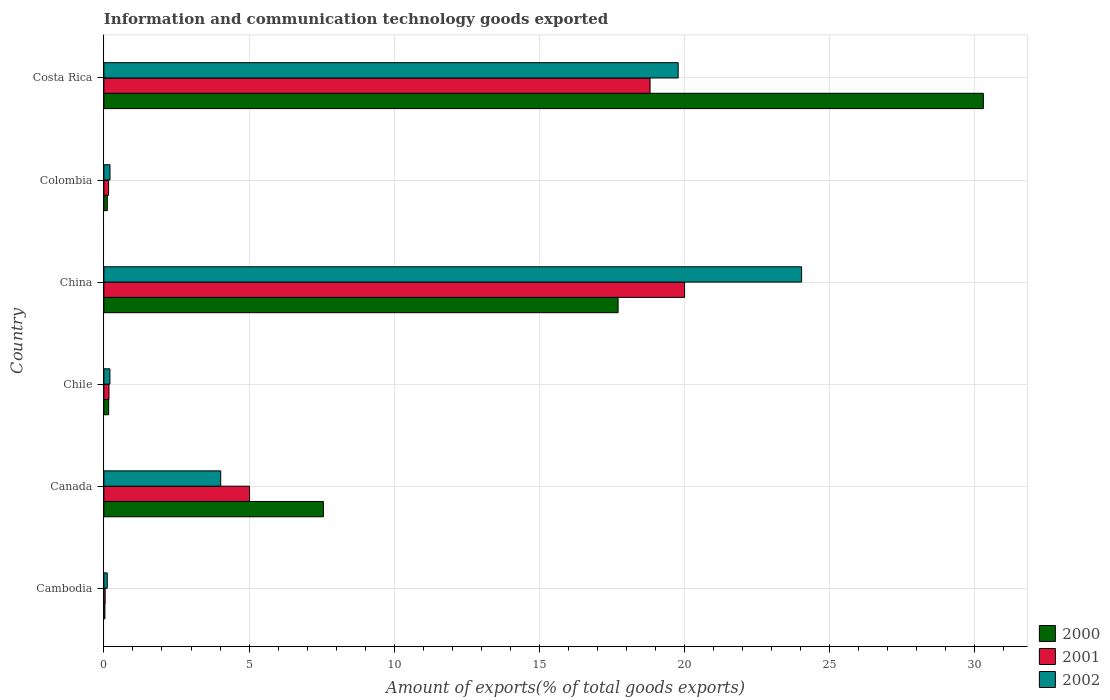How many different coloured bars are there?
Your response must be concise. 3. Are the number of bars per tick equal to the number of legend labels?
Your answer should be compact. Yes. In how many cases, is the number of bars for a given country not equal to the number of legend labels?
Offer a very short reply. 0. What is the amount of goods exported in 2002 in China?
Your answer should be very brief. 24.03. Across all countries, what is the maximum amount of goods exported in 2001?
Provide a succinct answer. 20. Across all countries, what is the minimum amount of goods exported in 2002?
Provide a short and direct response. 0.12. In which country was the amount of goods exported in 2000 maximum?
Your answer should be very brief. Costa Rica. In which country was the amount of goods exported in 2000 minimum?
Provide a succinct answer. Cambodia. What is the total amount of goods exported in 2002 in the graph?
Ensure brevity in your answer.  48.37. What is the difference between the amount of goods exported in 2001 in Colombia and that in Costa Rica?
Make the answer very short. -18.65. What is the difference between the amount of goods exported in 2002 in Canada and the amount of goods exported in 2001 in Chile?
Provide a short and direct response. 3.85. What is the average amount of goods exported in 2002 per country?
Your response must be concise. 8.06. What is the difference between the amount of goods exported in 2000 and amount of goods exported in 2002 in Chile?
Provide a short and direct response. -0.04. In how many countries, is the amount of goods exported in 2002 greater than 3 %?
Offer a terse response. 3. What is the ratio of the amount of goods exported in 2000 in Cambodia to that in Costa Rica?
Keep it short and to the point. 0. Is the amount of goods exported in 2001 in Chile less than that in Costa Rica?
Your answer should be compact. Yes. Is the difference between the amount of goods exported in 2000 in China and Colombia greater than the difference between the amount of goods exported in 2002 in China and Colombia?
Your answer should be compact. No. What is the difference between the highest and the second highest amount of goods exported in 2000?
Your response must be concise. 12.58. What is the difference between the highest and the lowest amount of goods exported in 2000?
Make the answer very short. 30.26. What does the 1st bar from the top in China represents?
Keep it short and to the point. 2002. Is it the case that in every country, the sum of the amount of goods exported in 2002 and amount of goods exported in 2001 is greater than the amount of goods exported in 2000?
Provide a succinct answer. Yes. How many bars are there?
Keep it short and to the point. 18. What is the difference between two consecutive major ticks on the X-axis?
Provide a short and direct response. 5. Does the graph contain any zero values?
Your response must be concise. No. How are the legend labels stacked?
Make the answer very short. Vertical. What is the title of the graph?
Make the answer very short. Information and communication technology goods exported. What is the label or title of the X-axis?
Your answer should be very brief. Amount of exports(% of total goods exports). What is the label or title of the Y-axis?
Keep it short and to the point. Country. What is the Amount of exports(% of total goods exports) in 2000 in Cambodia?
Give a very brief answer. 0.04. What is the Amount of exports(% of total goods exports) of 2001 in Cambodia?
Your answer should be compact. 0.04. What is the Amount of exports(% of total goods exports) in 2002 in Cambodia?
Ensure brevity in your answer.  0.12. What is the Amount of exports(% of total goods exports) in 2000 in Canada?
Provide a short and direct response. 7.56. What is the Amount of exports(% of total goods exports) in 2001 in Canada?
Offer a terse response. 5.02. What is the Amount of exports(% of total goods exports) in 2002 in Canada?
Ensure brevity in your answer.  4.02. What is the Amount of exports(% of total goods exports) in 2000 in Chile?
Your answer should be compact. 0.16. What is the Amount of exports(% of total goods exports) of 2001 in Chile?
Offer a terse response. 0.18. What is the Amount of exports(% of total goods exports) in 2002 in Chile?
Offer a very short reply. 0.21. What is the Amount of exports(% of total goods exports) of 2000 in China?
Give a very brief answer. 17.71. What is the Amount of exports(% of total goods exports) in 2001 in China?
Keep it short and to the point. 20. What is the Amount of exports(% of total goods exports) of 2002 in China?
Keep it short and to the point. 24.03. What is the Amount of exports(% of total goods exports) of 2000 in Colombia?
Make the answer very short. 0.12. What is the Amount of exports(% of total goods exports) of 2001 in Colombia?
Provide a short and direct response. 0.16. What is the Amount of exports(% of total goods exports) of 2002 in Colombia?
Provide a succinct answer. 0.21. What is the Amount of exports(% of total goods exports) of 2000 in Costa Rica?
Provide a short and direct response. 30.29. What is the Amount of exports(% of total goods exports) of 2001 in Costa Rica?
Offer a very short reply. 18.81. What is the Amount of exports(% of total goods exports) of 2002 in Costa Rica?
Provide a short and direct response. 19.78. Across all countries, what is the maximum Amount of exports(% of total goods exports) in 2000?
Keep it short and to the point. 30.29. Across all countries, what is the maximum Amount of exports(% of total goods exports) in 2001?
Provide a short and direct response. 20. Across all countries, what is the maximum Amount of exports(% of total goods exports) in 2002?
Your response must be concise. 24.03. Across all countries, what is the minimum Amount of exports(% of total goods exports) in 2000?
Your answer should be compact. 0.04. Across all countries, what is the minimum Amount of exports(% of total goods exports) in 2001?
Offer a very short reply. 0.04. Across all countries, what is the minimum Amount of exports(% of total goods exports) of 2002?
Give a very brief answer. 0.12. What is the total Amount of exports(% of total goods exports) in 2000 in the graph?
Offer a very short reply. 55.88. What is the total Amount of exports(% of total goods exports) in 2001 in the graph?
Offer a terse response. 44.21. What is the total Amount of exports(% of total goods exports) of 2002 in the graph?
Provide a succinct answer. 48.37. What is the difference between the Amount of exports(% of total goods exports) in 2000 in Cambodia and that in Canada?
Keep it short and to the point. -7.53. What is the difference between the Amount of exports(% of total goods exports) in 2001 in Cambodia and that in Canada?
Your answer should be very brief. -4.97. What is the difference between the Amount of exports(% of total goods exports) in 2002 in Cambodia and that in Canada?
Your answer should be compact. -3.91. What is the difference between the Amount of exports(% of total goods exports) of 2000 in Cambodia and that in Chile?
Offer a terse response. -0.13. What is the difference between the Amount of exports(% of total goods exports) in 2001 in Cambodia and that in Chile?
Your response must be concise. -0.13. What is the difference between the Amount of exports(% of total goods exports) of 2002 in Cambodia and that in Chile?
Provide a short and direct response. -0.09. What is the difference between the Amount of exports(% of total goods exports) of 2000 in Cambodia and that in China?
Offer a very short reply. -17.68. What is the difference between the Amount of exports(% of total goods exports) of 2001 in Cambodia and that in China?
Provide a short and direct response. -19.96. What is the difference between the Amount of exports(% of total goods exports) in 2002 in Cambodia and that in China?
Provide a succinct answer. -23.92. What is the difference between the Amount of exports(% of total goods exports) of 2000 in Cambodia and that in Colombia?
Keep it short and to the point. -0.08. What is the difference between the Amount of exports(% of total goods exports) of 2001 in Cambodia and that in Colombia?
Make the answer very short. -0.12. What is the difference between the Amount of exports(% of total goods exports) in 2002 in Cambodia and that in Colombia?
Your answer should be compact. -0.09. What is the difference between the Amount of exports(% of total goods exports) of 2000 in Cambodia and that in Costa Rica?
Offer a very short reply. -30.26. What is the difference between the Amount of exports(% of total goods exports) in 2001 in Cambodia and that in Costa Rica?
Your answer should be compact. -18.77. What is the difference between the Amount of exports(% of total goods exports) of 2002 in Cambodia and that in Costa Rica?
Keep it short and to the point. -19.66. What is the difference between the Amount of exports(% of total goods exports) of 2000 in Canada and that in Chile?
Provide a succinct answer. 7.4. What is the difference between the Amount of exports(% of total goods exports) in 2001 in Canada and that in Chile?
Give a very brief answer. 4.84. What is the difference between the Amount of exports(% of total goods exports) in 2002 in Canada and that in Chile?
Offer a terse response. 3.82. What is the difference between the Amount of exports(% of total goods exports) in 2000 in Canada and that in China?
Your response must be concise. -10.15. What is the difference between the Amount of exports(% of total goods exports) of 2001 in Canada and that in China?
Your answer should be very brief. -14.98. What is the difference between the Amount of exports(% of total goods exports) in 2002 in Canada and that in China?
Provide a short and direct response. -20.01. What is the difference between the Amount of exports(% of total goods exports) in 2000 in Canada and that in Colombia?
Give a very brief answer. 7.44. What is the difference between the Amount of exports(% of total goods exports) in 2001 in Canada and that in Colombia?
Ensure brevity in your answer.  4.85. What is the difference between the Amount of exports(% of total goods exports) in 2002 in Canada and that in Colombia?
Provide a succinct answer. 3.81. What is the difference between the Amount of exports(% of total goods exports) in 2000 in Canada and that in Costa Rica?
Provide a short and direct response. -22.73. What is the difference between the Amount of exports(% of total goods exports) of 2001 in Canada and that in Costa Rica?
Keep it short and to the point. -13.8. What is the difference between the Amount of exports(% of total goods exports) in 2002 in Canada and that in Costa Rica?
Your response must be concise. -15.76. What is the difference between the Amount of exports(% of total goods exports) of 2000 in Chile and that in China?
Provide a short and direct response. -17.55. What is the difference between the Amount of exports(% of total goods exports) of 2001 in Chile and that in China?
Provide a succinct answer. -19.82. What is the difference between the Amount of exports(% of total goods exports) in 2002 in Chile and that in China?
Offer a very short reply. -23.82. What is the difference between the Amount of exports(% of total goods exports) of 2000 in Chile and that in Colombia?
Your answer should be very brief. 0.05. What is the difference between the Amount of exports(% of total goods exports) of 2001 in Chile and that in Colombia?
Your answer should be compact. 0.01. What is the difference between the Amount of exports(% of total goods exports) in 2002 in Chile and that in Colombia?
Your answer should be compact. -0. What is the difference between the Amount of exports(% of total goods exports) in 2000 in Chile and that in Costa Rica?
Keep it short and to the point. -30.13. What is the difference between the Amount of exports(% of total goods exports) of 2001 in Chile and that in Costa Rica?
Keep it short and to the point. -18.64. What is the difference between the Amount of exports(% of total goods exports) of 2002 in Chile and that in Costa Rica?
Make the answer very short. -19.57. What is the difference between the Amount of exports(% of total goods exports) of 2000 in China and that in Colombia?
Ensure brevity in your answer.  17.59. What is the difference between the Amount of exports(% of total goods exports) in 2001 in China and that in Colombia?
Keep it short and to the point. 19.84. What is the difference between the Amount of exports(% of total goods exports) of 2002 in China and that in Colombia?
Ensure brevity in your answer.  23.82. What is the difference between the Amount of exports(% of total goods exports) in 2000 in China and that in Costa Rica?
Ensure brevity in your answer.  -12.58. What is the difference between the Amount of exports(% of total goods exports) in 2001 in China and that in Costa Rica?
Offer a terse response. 1.19. What is the difference between the Amount of exports(% of total goods exports) of 2002 in China and that in Costa Rica?
Make the answer very short. 4.25. What is the difference between the Amount of exports(% of total goods exports) in 2000 in Colombia and that in Costa Rica?
Your answer should be compact. -30.17. What is the difference between the Amount of exports(% of total goods exports) of 2001 in Colombia and that in Costa Rica?
Your answer should be compact. -18.65. What is the difference between the Amount of exports(% of total goods exports) in 2002 in Colombia and that in Costa Rica?
Provide a succinct answer. -19.57. What is the difference between the Amount of exports(% of total goods exports) in 2000 in Cambodia and the Amount of exports(% of total goods exports) in 2001 in Canada?
Offer a very short reply. -4.98. What is the difference between the Amount of exports(% of total goods exports) in 2000 in Cambodia and the Amount of exports(% of total goods exports) in 2002 in Canada?
Your answer should be very brief. -3.99. What is the difference between the Amount of exports(% of total goods exports) in 2001 in Cambodia and the Amount of exports(% of total goods exports) in 2002 in Canada?
Keep it short and to the point. -3.98. What is the difference between the Amount of exports(% of total goods exports) of 2000 in Cambodia and the Amount of exports(% of total goods exports) of 2001 in Chile?
Offer a terse response. -0.14. What is the difference between the Amount of exports(% of total goods exports) of 2000 in Cambodia and the Amount of exports(% of total goods exports) of 2002 in Chile?
Your answer should be compact. -0.17. What is the difference between the Amount of exports(% of total goods exports) in 2001 in Cambodia and the Amount of exports(% of total goods exports) in 2002 in Chile?
Make the answer very short. -0.16. What is the difference between the Amount of exports(% of total goods exports) of 2000 in Cambodia and the Amount of exports(% of total goods exports) of 2001 in China?
Provide a succinct answer. -19.97. What is the difference between the Amount of exports(% of total goods exports) of 2000 in Cambodia and the Amount of exports(% of total goods exports) of 2002 in China?
Offer a terse response. -24. What is the difference between the Amount of exports(% of total goods exports) in 2001 in Cambodia and the Amount of exports(% of total goods exports) in 2002 in China?
Offer a terse response. -23.99. What is the difference between the Amount of exports(% of total goods exports) in 2000 in Cambodia and the Amount of exports(% of total goods exports) in 2001 in Colombia?
Give a very brief answer. -0.13. What is the difference between the Amount of exports(% of total goods exports) of 2000 in Cambodia and the Amount of exports(% of total goods exports) of 2002 in Colombia?
Provide a succinct answer. -0.17. What is the difference between the Amount of exports(% of total goods exports) in 2001 in Cambodia and the Amount of exports(% of total goods exports) in 2002 in Colombia?
Make the answer very short. -0.17. What is the difference between the Amount of exports(% of total goods exports) in 2000 in Cambodia and the Amount of exports(% of total goods exports) in 2001 in Costa Rica?
Provide a succinct answer. -18.78. What is the difference between the Amount of exports(% of total goods exports) of 2000 in Cambodia and the Amount of exports(% of total goods exports) of 2002 in Costa Rica?
Your answer should be compact. -19.74. What is the difference between the Amount of exports(% of total goods exports) of 2001 in Cambodia and the Amount of exports(% of total goods exports) of 2002 in Costa Rica?
Offer a very short reply. -19.74. What is the difference between the Amount of exports(% of total goods exports) in 2000 in Canada and the Amount of exports(% of total goods exports) in 2001 in Chile?
Ensure brevity in your answer.  7.38. What is the difference between the Amount of exports(% of total goods exports) of 2000 in Canada and the Amount of exports(% of total goods exports) of 2002 in Chile?
Your answer should be compact. 7.35. What is the difference between the Amount of exports(% of total goods exports) of 2001 in Canada and the Amount of exports(% of total goods exports) of 2002 in Chile?
Offer a terse response. 4.81. What is the difference between the Amount of exports(% of total goods exports) of 2000 in Canada and the Amount of exports(% of total goods exports) of 2001 in China?
Keep it short and to the point. -12.44. What is the difference between the Amount of exports(% of total goods exports) in 2000 in Canada and the Amount of exports(% of total goods exports) in 2002 in China?
Provide a succinct answer. -16.47. What is the difference between the Amount of exports(% of total goods exports) of 2001 in Canada and the Amount of exports(% of total goods exports) of 2002 in China?
Make the answer very short. -19.01. What is the difference between the Amount of exports(% of total goods exports) in 2000 in Canada and the Amount of exports(% of total goods exports) in 2001 in Colombia?
Offer a terse response. 7.4. What is the difference between the Amount of exports(% of total goods exports) of 2000 in Canada and the Amount of exports(% of total goods exports) of 2002 in Colombia?
Ensure brevity in your answer.  7.35. What is the difference between the Amount of exports(% of total goods exports) in 2001 in Canada and the Amount of exports(% of total goods exports) in 2002 in Colombia?
Your answer should be very brief. 4.81. What is the difference between the Amount of exports(% of total goods exports) of 2000 in Canada and the Amount of exports(% of total goods exports) of 2001 in Costa Rica?
Provide a short and direct response. -11.25. What is the difference between the Amount of exports(% of total goods exports) of 2000 in Canada and the Amount of exports(% of total goods exports) of 2002 in Costa Rica?
Give a very brief answer. -12.22. What is the difference between the Amount of exports(% of total goods exports) in 2001 in Canada and the Amount of exports(% of total goods exports) in 2002 in Costa Rica?
Offer a very short reply. -14.76. What is the difference between the Amount of exports(% of total goods exports) in 2000 in Chile and the Amount of exports(% of total goods exports) in 2001 in China?
Your answer should be compact. -19.84. What is the difference between the Amount of exports(% of total goods exports) of 2000 in Chile and the Amount of exports(% of total goods exports) of 2002 in China?
Offer a terse response. -23.87. What is the difference between the Amount of exports(% of total goods exports) in 2001 in Chile and the Amount of exports(% of total goods exports) in 2002 in China?
Your answer should be very brief. -23.86. What is the difference between the Amount of exports(% of total goods exports) in 2000 in Chile and the Amount of exports(% of total goods exports) in 2001 in Colombia?
Make the answer very short. 0. What is the difference between the Amount of exports(% of total goods exports) in 2000 in Chile and the Amount of exports(% of total goods exports) in 2002 in Colombia?
Provide a succinct answer. -0.05. What is the difference between the Amount of exports(% of total goods exports) of 2001 in Chile and the Amount of exports(% of total goods exports) of 2002 in Colombia?
Offer a very short reply. -0.03. What is the difference between the Amount of exports(% of total goods exports) of 2000 in Chile and the Amount of exports(% of total goods exports) of 2001 in Costa Rica?
Your answer should be compact. -18.65. What is the difference between the Amount of exports(% of total goods exports) of 2000 in Chile and the Amount of exports(% of total goods exports) of 2002 in Costa Rica?
Make the answer very short. -19.61. What is the difference between the Amount of exports(% of total goods exports) in 2001 in Chile and the Amount of exports(% of total goods exports) in 2002 in Costa Rica?
Your answer should be very brief. -19.6. What is the difference between the Amount of exports(% of total goods exports) of 2000 in China and the Amount of exports(% of total goods exports) of 2001 in Colombia?
Make the answer very short. 17.55. What is the difference between the Amount of exports(% of total goods exports) of 2000 in China and the Amount of exports(% of total goods exports) of 2002 in Colombia?
Offer a very short reply. 17.5. What is the difference between the Amount of exports(% of total goods exports) of 2001 in China and the Amount of exports(% of total goods exports) of 2002 in Colombia?
Offer a very short reply. 19.79. What is the difference between the Amount of exports(% of total goods exports) of 2000 in China and the Amount of exports(% of total goods exports) of 2001 in Costa Rica?
Give a very brief answer. -1.1. What is the difference between the Amount of exports(% of total goods exports) in 2000 in China and the Amount of exports(% of total goods exports) in 2002 in Costa Rica?
Your response must be concise. -2.07. What is the difference between the Amount of exports(% of total goods exports) of 2001 in China and the Amount of exports(% of total goods exports) of 2002 in Costa Rica?
Keep it short and to the point. 0.22. What is the difference between the Amount of exports(% of total goods exports) of 2000 in Colombia and the Amount of exports(% of total goods exports) of 2001 in Costa Rica?
Ensure brevity in your answer.  -18.69. What is the difference between the Amount of exports(% of total goods exports) in 2000 in Colombia and the Amount of exports(% of total goods exports) in 2002 in Costa Rica?
Offer a very short reply. -19.66. What is the difference between the Amount of exports(% of total goods exports) in 2001 in Colombia and the Amount of exports(% of total goods exports) in 2002 in Costa Rica?
Your response must be concise. -19.62. What is the average Amount of exports(% of total goods exports) in 2000 per country?
Keep it short and to the point. 9.31. What is the average Amount of exports(% of total goods exports) of 2001 per country?
Offer a very short reply. 7.37. What is the average Amount of exports(% of total goods exports) in 2002 per country?
Keep it short and to the point. 8.06. What is the difference between the Amount of exports(% of total goods exports) in 2000 and Amount of exports(% of total goods exports) in 2001 in Cambodia?
Your answer should be very brief. -0.01. What is the difference between the Amount of exports(% of total goods exports) of 2000 and Amount of exports(% of total goods exports) of 2002 in Cambodia?
Offer a terse response. -0.08. What is the difference between the Amount of exports(% of total goods exports) of 2001 and Amount of exports(% of total goods exports) of 2002 in Cambodia?
Ensure brevity in your answer.  -0.07. What is the difference between the Amount of exports(% of total goods exports) of 2000 and Amount of exports(% of total goods exports) of 2001 in Canada?
Ensure brevity in your answer.  2.54. What is the difference between the Amount of exports(% of total goods exports) of 2000 and Amount of exports(% of total goods exports) of 2002 in Canada?
Give a very brief answer. 3.54. What is the difference between the Amount of exports(% of total goods exports) in 2001 and Amount of exports(% of total goods exports) in 2002 in Canada?
Your answer should be compact. 0.99. What is the difference between the Amount of exports(% of total goods exports) of 2000 and Amount of exports(% of total goods exports) of 2001 in Chile?
Keep it short and to the point. -0.01. What is the difference between the Amount of exports(% of total goods exports) in 2000 and Amount of exports(% of total goods exports) in 2002 in Chile?
Your answer should be compact. -0.04. What is the difference between the Amount of exports(% of total goods exports) in 2001 and Amount of exports(% of total goods exports) in 2002 in Chile?
Offer a very short reply. -0.03. What is the difference between the Amount of exports(% of total goods exports) in 2000 and Amount of exports(% of total goods exports) in 2001 in China?
Offer a terse response. -2.29. What is the difference between the Amount of exports(% of total goods exports) in 2000 and Amount of exports(% of total goods exports) in 2002 in China?
Your response must be concise. -6.32. What is the difference between the Amount of exports(% of total goods exports) of 2001 and Amount of exports(% of total goods exports) of 2002 in China?
Provide a succinct answer. -4.03. What is the difference between the Amount of exports(% of total goods exports) of 2000 and Amount of exports(% of total goods exports) of 2001 in Colombia?
Your response must be concise. -0.04. What is the difference between the Amount of exports(% of total goods exports) in 2000 and Amount of exports(% of total goods exports) in 2002 in Colombia?
Your response must be concise. -0.09. What is the difference between the Amount of exports(% of total goods exports) in 2001 and Amount of exports(% of total goods exports) in 2002 in Colombia?
Your response must be concise. -0.05. What is the difference between the Amount of exports(% of total goods exports) of 2000 and Amount of exports(% of total goods exports) of 2001 in Costa Rica?
Make the answer very short. 11.48. What is the difference between the Amount of exports(% of total goods exports) in 2000 and Amount of exports(% of total goods exports) in 2002 in Costa Rica?
Provide a succinct answer. 10.51. What is the difference between the Amount of exports(% of total goods exports) of 2001 and Amount of exports(% of total goods exports) of 2002 in Costa Rica?
Provide a short and direct response. -0.97. What is the ratio of the Amount of exports(% of total goods exports) of 2000 in Cambodia to that in Canada?
Provide a short and direct response. 0. What is the ratio of the Amount of exports(% of total goods exports) of 2001 in Cambodia to that in Canada?
Your answer should be compact. 0.01. What is the ratio of the Amount of exports(% of total goods exports) in 2002 in Cambodia to that in Canada?
Make the answer very short. 0.03. What is the ratio of the Amount of exports(% of total goods exports) of 2000 in Cambodia to that in Chile?
Offer a very short reply. 0.21. What is the ratio of the Amount of exports(% of total goods exports) in 2001 in Cambodia to that in Chile?
Provide a short and direct response. 0.25. What is the ratio of the Amount of exports(% of total goods exports) of 2002 in Cambodia to that in Chile?
Offer a very short reply. 0.56. What is the ratio of the Amount of exports(% of total goods exports) of 2000 in Cambodia to that in China?
Your response must be concise. 0. What is the ratio of the Amount of exports(% of total goods exports) in 2001 in Cambodia to that in China?
Provide a succinct answer. 0. What is the ratio of the Amount of exports(% of total goods exports) of 2002 in Cambodia to that in China?
Your answer should be very brief. 0. What is the ratio of the Amount of exports(% of total goods exports) in 2000 in Cambodia to that in Colombia?
Provide a succinct answer. 0.3. What is the ratio of the Amount of exports(% of total goods exports) of 2001 in Cambodia to that in Colombia?
Provide a short and direct response. 0.27. What is the ratio of the Amount of exports(% of total goods exports) in 2002 in Cambodia to that in Colombia?
Offer a very short reply. 0.55. What is the ratio of the Amount of exports(% of total goods exports) in 2000 in Cambodia to that in Costa Rica?
Keep it short and to the point. 0. What is the ratio of the Amount of exports(% of total goods exports) in 2001 in Cambodia to that in Costa Rica?
Provide a short and direct response. 0. What is the ratio of the Amount of exports(% of total goods exports) of 2002 in Cambodia to that in Costa Rica?
Your answer should be very brief. 0.01. What is the ratio of the Amount of exports(% of total goods exports) in 2000 in Canada to that in Chile?
Keep it short and to the point. 45.9. What is the ratio of the Amount of exports(% of total goods exports) of 2001 in Canada to that in Chile?
Offer a terse response. 28.58. What is the ratio of the Amount of exports(% of total goods exports) of 2002 in Canada to that in Chile?
Make the answer very short. 19.43. What is the ratio of the Amount of exports(% of total goods exports) of 2000 in Canada to that in China?
Offer a terse response. 0.43. What is the ratio of the Amount of exports(% of total goods exports) in 2001 in Canada to that in China?
Keep it short and to the point. 0.25. What is the ratio of the Amount of exports(% of total goods exports) of 2002 in Canada to that in China?
Offer a very short reply. 0.17. What is the ratio of the Amount of exports(% of total goods exports) in 2000 in Canada to that in Colombia?
Make the answer very short. 64.4. What is the ratio of the Amount of exports(% of total goods exports) of 2001 in Canada to that in Colombia?
Your answer should be very brief. 31.15. What is the ratio of the Amount of exports(% of total goods exports) of 2002 in Canada to that in Colombia?
Provide a succinct answer. 19.15. What is the ratio of the Amount of exports(% of total goods exports) in 2000 in Canada to that in Costa Rica?
Provide a succinct answer. 0.25. What is the ratio of the Amount of exports(% of total goods exports) in 2001 in Canada to that in Costa Rica?
Provide a succinct answer. 0.27. What is the ratio of the Amount of exports(% of total goods exports) of 2002 in Canada to that in Costa Rica?
Offer a very short reply. 0.2. What is the ratio of the Amount of exports(% of total goods exports) in 2000 in Chile to that in China?
Make the answer very short. 0.01. What is the ratio of the Amount of exports(% of total goods exports) of 2001 in Chile to that in China?
Your answer should be very brief. 0.01. What is the ratio of the Amount of exports(% of total goods exports) of 2002 in Chile to that in China?
Make the answer very short. 0.01. What is the ratio of the Amount of exports(% of total goods exports) of 2000 in Chile to that in Colombia?
Give a very brief answer. 1.4. What is the ratio of the Amount of exports(% of total goods exports) of 2001 in Chile to that in Colombia?
Give a very brief answer. 1.09. What is the ratio of the Amount of exports(% of total goods exports) of 2002 in Chile to that in Colombia?
Your answer should be very brief. 0.99. What is the ratio of the Amount of exports(% of total goods exports) in 2000 in Chile to that in Costa Rica?
Give a very brief answer. 0.01. What is the ratio of the Amount of exports(% of total goods exports) in 2001 in Chile to that in Costa Rica?
Your answer should be very brief. 0.01. What is the ratio of the Amount of exports(% of total goods exports) of 2002 in Chile to that in Costa Rica?
Offer a terse response. 0.01. What is the ratio of the Amount of exports(% of total goods exports) in 2000 in China to that in Colombia?
Your response must be concise. 150.86. What is the ratio of the Amount of exports(% of total goods exports) of 2001 in China to that in Colombia?
Make the answer very short. 124.19. What is the ratio of the Amount of exports(% of total goods exports) in 2002 in China to that in Colombia?
Offer a terse response. 114.39. What is the ratio of the Amount of exports(% of total goods exports) in 2000 in China to that in Costa Rica?
Your response must be concise. 0.58. What is the ratio of the Amount of exports(% of total goods exports) of 2001 in China to that in Costa Rica?
Ensure brevity in your answer.  1.06. What is the ratio of the Amount of exports(% of total goods exports) in 2002 in China to that in Costa Rica?
Your answer should be very brief. 1.21. What is the ratio of the Amount of exports(% of total goods exports) in 2000 in Colombia to that in Costa Rica?
Offer a terse response. 0. What is the ratio of the Amount of exports(% of total goods exports) of 2001 in Colombia to that in Costa Rica?
Make the answer very short. 0.01. What is the ratio of the Amount of exports(% of total goods exports) of 2002 in Colombia to that in Costa Rica?
Offer a very short reply. 0.01. What is the difference between the highest and the second highest Amount of exports(% of total goods exports) in 2000?
Provide a succinct answer. 12.58. What is the difference between the highest and the second highest Amount of exports(% of total goods exports) of 2001?
Provide a succinct answer. 1.19. What is the difference between the highest and the second highest Amount of exports(% of total goods exports) in 2002?
Ensure brevity in your answer.  4.25. What is the difference between the highest and the lowest Amount of exports(% of total goods exports) in 2000?
Make the answer very short. 30.26. What is the difference between the highest and the lowest Amount of exports(% of total goods exports) of 2001?
Your answer should be very brief. 19.96. What is the difference between the highest and the lowest Amount of exports(% of total goods exports) in 2002?
Provide a succinct answer. 23.92. 